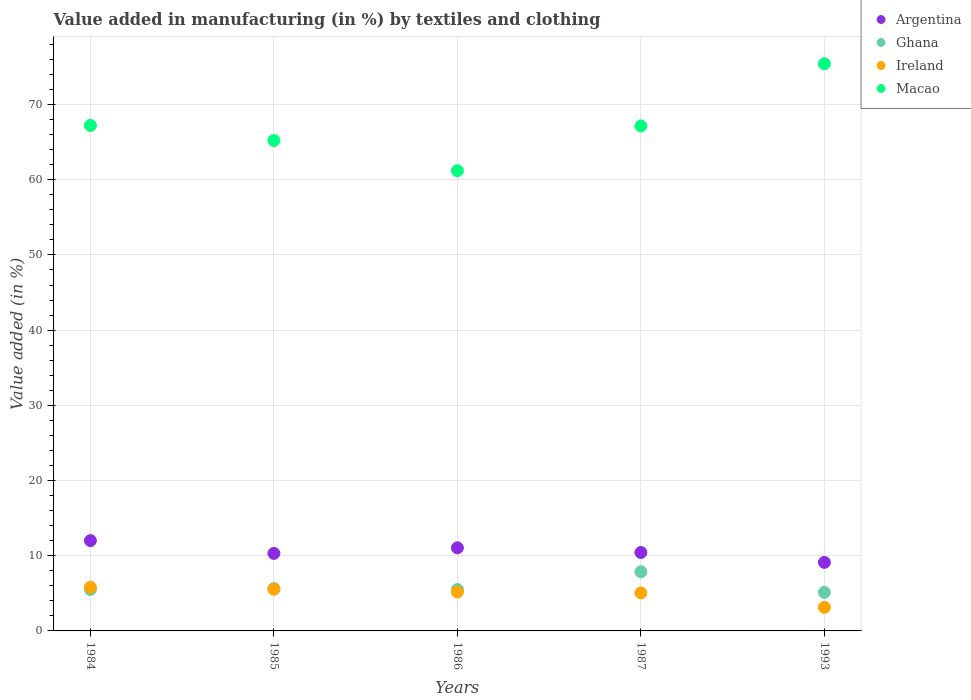What is the percentage of value added in manufacturing by textiles and clothing in Macao in 1987?
Provide a short and direct response. 67.15. Across all years, what is the maximum percentage of value added in manufacturing by textiles and clothing in Argentina?
Offer a terse response. 12.01. Across all years, what is the minimum percentage of value added in manufacturing by textiles and clothing in Macao?
Your answer should be compact. 61.21. In which year was the percentage of value added in manufacturing by textiles and clothing in Macao maximum?
Make the answer very short. 1993. In which year was the percentage of value added in manufacturing by textiles and clothing in Ireland minimum?
Offer a very short reply. 1993. What is the total percentage of value added in manufacturing by textiles and clothing in Ireland in the graph?
Ensure brevity in your answer.  24.72. What is the difference between the percentage of value added in manufacturing by textiles and clothing in Ireland in 1984 and that in 1986?
Your answer should be very brief. 0.62. What is the difference between the percentage of value added in manufacturing by textiles and clothing in Ireland in 1984 and the percentage of value added in manufacturing by textiles and clothing in Macao in 1987?
Offer a very short reply. -61.35. What is the average percentage of value added in manufacturing by textiles and clothing in Ghana per year?
Provide a succinct answer. 5.93. In the year 1986, what is the difference between the percentage of value added in manufacturing by textiles and clothing in Ireland and percentage of value added in manufacturing by textiles and clothing in Ghana?
Provide a short and direct response. -0.32. In how many years, is the percentage of value added in manufacturing by textiles and clothing in Argentina greater than 66 %?
Offer a terse response. 0. What is the ratio of the percentage of value added in manufacturing by textiles and clothing in Ghana in 1984 to that in 1987?
Ensure brevity in your answer.  0.7. Is the percentage of value added in manufacturing by textiles and clothing in Ghana in 1985 less than that in 1986?
Make the answer very short. No. Is the difference between the percentage of value added in manufacturing by textiles and clothing in Ireland in 1984 and 1987 greater than the difference between the percentage of value added in manufacturing by textiles and clothing in Ghana in 1984 and 1987?
Your answer should be very brief. Yes. What is the difference between the highest and the second highest percentage of value added in manufacturing by textiles and clothing in Macao?
Offer a terse response. 8.2. What is the difference between the highest and the lowest percentage of value added in manufacturing by textiles and clothing in Macao?
Ensure brevity in your answer.  14.22. Is it the case that in every year, the sum of the percentage of value added in manufacturing by textiles and clothing in Ghana and percentage of value added in manufacturing by textiles and clothing in Macao  is greater than the sum of percentage of value added in manufacturing by textiles and clothing in Ireland and percentage of value added in manufacturing by textiles and clothing in Argentina?
Offer a very short reply. Yes. Is the percentage of value added in manufacturing by textiles and clothing in Argentina strictly greater than the percentage of value added in manufacturing by textiles and clothing in Ireland over the years?
Provide a succinct answer. Yes. Is the percentage of value added in manufacturing by textiles and clothing in Ghana strictly less than the percentage of value added in manufacturing by textiles and clothing in Macao over the years?
Offer a terse response. Yes. How many dotlines are there?
Your answer should be compact. 4. What is the difference between two consecutive major ticks on the Y-axis?
Your answer should be very brief. 10. Are the values on the major ticks of Y-axis written in scientific E-notation?
Provide a succinct answer. No. Does the graph contain any zero values?
Your answer should be very brief. No. Does the graph contain grids?
Ensure brevity in your answer.  Yes. What is the title of the graph?
Offer a very short reply. Value added in manufacturing (in %) by textiles and clothing. Does "Slovenia" appear as one of the legend labels in the graph?
Ensure brevity in your answer.  No. What is the label or title of the X-axis?
Your response must be concise. Years. What is the label or title of the Y-axis?
Your answer should be very brief. Value added (in %). What is the Value added (in %) of Argentina in 1984?
Give a very brief answer. 12.01. What is the Value added (in %) of Ghana in 1984?
Keep it short and to the point. 5.51. What is the Value added (in %) in Ireland in 1984?
Offer a terse response. 5.81. What is the Value added (in %) of Macao in 1984?
Keep it short and to the point. 67.23. What is the Value added (in %) in Argentina in 1985?
Ensure brevity in your answer.  10.31. What is the Value added (in %) of Ghana in 1985?
Give a very brief answer. 5.64. What is the Value added (in %) of Ireland in 1985?
Provide a short and direct response. 5.54. What is the Value added (in %) of Macao in 1985?
Keep it short and to the point. 65.22. What is the Value added (in %) of Argentina in 1986?
Your response must be concise. 11.05. What is the Value added (in %) of Ghana in 1986?
Offer a terse response. 5.51. What is the Value added (in %) of Ireland in 1986?
Make the answer very short. 5.18. What is the Value added (in %) of Macao in 1986?
Provide a short and direct response. 61.21. What is the Value added (in %) of Argentina in 1987?
Make the answer very short. 10.43. What is the Value added (in %) of Ghana in 1987?
Keep it short and to the point. 7.87. What is the Value added (in %) in Ireland in 1987?
Give a very brief answer. 5.06. What is the Value added (in %) of Macao in 1987?
Your answer should be very brief. 67.15. What is the Value added (in %) of Argentina in 1993?
Give a very brief answer. 9.12. What is the Value added (in %) in Ghana in 1993?
Provide a succinct answer. 5.13. What is the Value added (in %) in Ireland in 1993?
Your response must be concise. 3.13. What is the Value added (in %) of Macao in 1993?
Make the answer very short. 75.43. Across all years, what is the maximum Value added (in %) in Argentina?
Provide a succinct answer. 12.01. Across all years, what is the maximum Value added (in %) in Ghana?
Your answer should be very brief. 7.87. Across all years, what is the maximum Value added (in %) in Ireland?
Keep it short and to the point. 5.81. Across all years, what is the maximum Value added (in %) of Macao?
Provide a succinct answer. 75.43. Across all years, what is the minimum Value added (in %) in Argentina?
Make the answer very short. 9.12. Across all years, what is the minimum Value added (in %) of Ghana?
Offer a terse response. 5.13. Across all years, what is the minimum Value added (in %) in Ireland?
Keep it short and to the point. 3.13. Across all years, what is the minimum Value added (in %) of Macao?
Provide a short and direct response. 61.21. What is the total Value added (in %) of Argentina in the graph?
Keep it short and to the point. 52.91. What is the total Value added (in %) of Ghana in the graph?
Your response must be concise. 29.66. What is the total Value added (in %) of Ireland in the graph?
Make the answer very short. 24.72. What is the total Value added (in %) in Macao in the graph?
Your answer should be very brief. 336.24. What is the difference between the Value added (in %) in Argentina in 1984 and that in 1985?
Give a very brief answer. 1.7. What is the difference between the Value added (in %) of Ghana in 1984 and that in 1985?
Your answer should be compact. -0.13. What is the difference between the Value added (in %) of Ireland in 1984 and that in 1985?
Keep it short and to the point. 0.27. What is the difference between the Value added (in %) of Macao in 1984 and that in 1985?
Offer a very short reply. 2. What is the difference between the Value added (in %) in Ghana in 1984 and that in 1986?
Your response must be concise. 0. What is the difference between the Value added (in %) in Ireland in 1984 and that in 1986?
Ensure brevity in your answer.  0.62. What is the difference between the Value added (in %) in Macao in 1984 and that in 1986?
Give a very brief answer. 6.02. What is the difference between the Value added (in %) of Argentina in 1984 and that in 1987?
Your response must be concise. 1.58. What is the difference between the Value added (in %) of Ghana in 1984 and that in 1987?
Provide a short and direct response. -2.36. What is the difference between the Value added (in %) of Ireland in 1984 and that in 1987?
Keep it short and to the point. 0.75. What is the difference between the Value added (in %) in Macao in 1984 and that in 1987?
Your answer should be compact. 0.08. What is the difference between the Value added (in %) of Argentina in 1984 and that in 1993?
Your response must be concise. 2.89. What is the difference between the Value added (in %) of Ghana in 1984 and that in 1993?
Your answer should be compact. 0.38. What is the difference between the Value added (in %) in Ireland in 1984 and that in 1993?
Give a very brief answer. 2.67. What is the difference between the Value added (in %) of Macao in 1984 and that in 1993?
Make the answer very short. -8.2. What is the difference between the Value added (in %) of Argentina in 1985 and that in 1986?
Ensure brevity in your answer.  -0.74. What is the difference between the Value added (in %) in Ghana in 1985 and that in 1986?
Your response must be concise. 0.14. What is the difference between the Value added (in %) of Ireland in 1985 and that in 1986?
Your answer should be very brief. 0.35. What is the difference between the Value added (in %) of Macao in 1985 and that in 1986?
Provide a succinct answer. 4.02. What is the difference between the Value added (in %) in Argentina in 1985 and that in 1987?
Your answer should be compact. -0.12. What is the difference between the Value added (in %) of Ghana in 1985 and that in 1987?
Your response must be concise. -2.23. What is the difference between the Value added (in %) in Ireland in 1985 and that in 1987?
Offer a very short reply. 0.48. What is the difference between the Value added (in %) in Macao in 1985 and that in 1987?
Ensure brevity in your answer.  -1.93. What is the difference between the Value added (in %) in Argentina in 1985 and that in 1993?
Keep it short and to the point. 1.19. What is the difference between the Value added (in %) in Ghana in 1985 and that in 1993?
Keep it short and to the point. 0.51. What is the difference between the Value added (in %) in Ireland in 1985 and that in 1993?
Your answer should be very brief. 2.41. What is the difference between the Value added (in %) of Macao in 1985 and that in 1993?
Your response must be concise. -10.21. What is the difference between the Value added (in %) in Argentina in 1986 and that in 1987?
Offer a very short reply. 0.62. What is the difference between the Value added (in %) of Ghana in 1986 and that in 1987?
Offer a terse response. -2.36. What is the difference between the Value added (in %) in Ireland in 1986 and that in 1987?
Keep it short and to the point. 0.13. What is the difference between the Value added (in %) of Macao in 1986 and that in 1987?
Keep it short and to the point. -5.94. What is the difference between the Value added (in %) in Argentina in 1986 and that in 1993?
Give a very brief answer. 1.93. What is the difference between the Value added (in %) of Ghana in 1986 and that in 1993?
Give a very brief answer. 0.38. What is the difference between the Value added (in %) in Ireland in 1986 and that in 1993?
Make the answer very short. 2.05. What is the difference between the Value added (in %) in Macao in 1986 and that in 1993?
Offer a terse response. -14.22. What is the difference between the Value added (in %) in Argentina in 1987 and that in 1993?
Make the answer very short. 1.31. What is the difference between the Value added (in %) in Ghana in 1987 and that in 1993?
Make the answer very short. 2.74. What is the difference between the Value added (in %) in Ireland in 1987 and that in 1993?
Your answer should be very brief. 1.93. What is the difference between the Value added (in %) in Macao in 1987 and that in 1993?
Offer a terse response. -8.28. What is the difference between the Value added (in %) of Argentina in 1984 and the Value added (in %) of Ghana in 1985?
Keep it short and to the point. 6.36. What is the difference between the Value added (in %) in Argentina in 1984 and the Value added (in %) in Ireland in 1985?
Your answer should be very brief. 6.47. What is the difference between the Value added (in %) of Argentina in 1984 and the Value added (in %) of Macao in 1985?
Make the answer very short. -53.22. What is the difference between the Value added (in %) in Ghana in 1984 and the Value added (in %) in Ireland in 1985?
Your response must be concise. -0.03. What is the difference between the Value added (in %) of Ghana in 1984 and the Value added (in %) of Macao in 1985?
Offer a very short reply. -59.71. What is the difference between the Value added (in %) of Ireland in 1984 and the Value added (in %) of Macao in 1985?
Provide a short and direct response. -59.42. What is the difference between the Value added (in %) of Argentina in 1984 and the Value added (in %) of Ghana in 1986?
Provide a short and direct response. 6.5. What is the difference between the Value added (in %) of Argentina in 1984 and the Value added (in %) of Ireland in 1986?
Keep it short and to the point. 6.82. What is the difference between the Value added (in %) in Argentina in 1984 and the Value added (in %) in Macao in 1986?
Ensure brevity in your answer.  -49.2. What is the difference between the Value added (in %) in Ghana in 1984 and the Value added (in %) in Ireland in 1986?
Offer a terse response. 0.33. What is the difference between the Value added (in %) in Ghana in 1984 and the Value added (in %) in Macao in 1986?
Make the answer very short. -55.7. What is the difference between the Value added (in %) of Ireland in 1984 and the Value added (in %) of Macao in 1986?
Offer a very short reply. -55.4. What is the difference between the Value added (in %) in Argentina in 1984 and the Value added (in %) in Ghana in 1987?
Provide a succinct answer. 4.14. What is the difference between the Value added (in %) in Argentina in 1984 and the Value added (in %) in Ireland in 1987?
Provide a succinct answer. 6.95. What is the difference between the Value added (in %) of Argentina in 1984 and the Value added (in %) of Macao in 1987?
Keep it short and to the point. -55.14. What is the difference between the Value added (in %) in Ghana in 1984 and the Value added (in %) in Ireland in 1987?
Ensure brevity in your answer.  0.45. What is the difference between the Value added (in %) in Ghana in 1984 and the Value added (in %) in Macao in 1987?
Provide a succinct answer. -61.64. What is the difference between the Value added (in %) in Ireland in 1984 and the Value added (in %) in Macao in 1987?
Keep it short and to the point. -61.35. What is the difference between the Value added (in %) in Argentina in 1984 and the Value added (in %) in Ghana in 1993?
Your answer should be very brief. 6.88. What is the difference between the Value added (in %) of Argentina in 1984 and the Value added (in %) of Ireland in 1993?
Give a very brief answer. 8.88. What is the difference between the Value added (in %) of Argentina in 1984 and the Value added (in %) of Macao in 1993?
Offer a terse response. -63.42. What is the difference between the Value added (in %) of Ghana in 1984 and the Value added (in %) of Ireland in 1993?
Your answer should be compact. 2.38. What is the difference between the Value added (in %) in Ghana in 1984 and the Value added (in %) in Macao in 1993?
Keep it short and to the point. -69.92. What is the difference between the Value added (in %) of Ireland in 1984 and the Value added (in %) of Macao in 1993?
Your response must be concise. -69.62. What is the difference between the Value added (in %) in Argentina in 1985 and the Value added (in %) in Ghana in 1986?
Keep it short and to the point. 4.8. What is the difference between the Value added (in %) of Argentina in 1985 and the Value added (in %) of Ireland in 1986?
Your response must be concise. 5.13. What is the difference between the Value added (in %) in Argentina in 1985 and the Value added (in %) in Macao in 1986?
Give a very brief answer. -50.9. What is the difference between the Value added (in %) of Ghana in 1985 and the Value added (in %) of Ireland in 1986?
Offer a very short reply. 0.46. What is the difference between the Value added (in %) of Ghana in 1985 and the Value added (in %) of Macao in 1986?
Make the answer very short. -55.56. What is the difference between the Value added (in %) of Ireland in 1985 and the Value added (in %) of Macao in 1986?
Keep it short and to the point. -55.67. What is the difference between the Value added (in %) in Argentina in 1985 and the Value added (in %) in Ghana in 1987?
Your answer should be compact. 2.44. What is the difference between the Value added (in %) of Argentina in 1985 and the Value added (in %) of Ireland in 1987?
Your response must be concise. 5.25. What is the difference between the Value added (in %) in Argentina in 1985 and the Value added (in %) in Macao in 1987?
Your response must be concise. -56.84. What is the difference between the Value added (in %) in Ghana in 1985 and the Value added (in %) in Ireland in 1987?
Make the answer very short. 0.59. What is the difference between the Value added (in %) of Ghana in 1985 and the Value added (in %) of Macao in 1987?
Keep it short and to the point. -61.51. What is the difference between the Value added (in %) in Ireland in 1985 and the Value added (in %) in Macao in 1987?
Your response must be concise. -61.61. What is the difference between the Value added (in %) in Argentina in 1985 and the Value added (in %) in Ghana in 1993?
Your response must be concise. 5.18. What is the difference between the Value added (in %) of Argentina in 1985 and the Value added (in %) of Ireland in 1993?
Your answer should be compact. 7.18. What is the difference between the Value added (in %) of Argentina in 1985 and the Value added (in %) of Macao in 1993?
Provide a short and direct response. -65.12. What is the difference between the Value added (in %) of Ghana in 1985 and the Value added (in %) of Ireland in 1993?
Your answer should be compact. 2.51. What is the difference between the Value added (in %) of Ghana in 1985 and the Value added (in %) of Macao in 1993?
Ensure brevity in your answer.  -69.79. What is the difference between the Value added (in %) in Ireland in 1985 and the Value added (in %) in Macao in 1993?
Offer a very short reply. -69.89. What is the difference between the Value added (in %) in Argentina in 1986 and the Value added (in %) in Ghana in 1987?
Your response must be concise. 3.18. What is the difference between the Value added (in %) in Argentina in 1986 and the Value added (in %) in Ireland in 1987?
Make the answer very short. 5.99. What is the difference between the Value added (in %) of Argentina in 1986 and the Value added (in %) of Macao in 1987?
Ensure brevity in your answer.  -56.1. What is the difference between the Value added (in %) in Ghana in 1986 and the Value added (in %) in Ireland in 1987?
Offer a very short reply. 0.45. What is the difference between the Value added (in %) of Ghana in 1986 and the Value added (in %) of Macao in 1987?
Make the answer very short. -61.64. What is the difference between the Value added (in %) of Ireland in 1986 and the Value added (in %) of Macao in 1987?
Your answer should be very brief. -61.97. What is the difference between the Value added (in %) of Argentina in 1986 and the Value added (in %) of Ghana in 1993?
Ensure brevity in your answer.  5.92. What is the difference between the Value added (in %) of Argentina in 1986 and the Value added (in %) of Ireland in 1993?
Offer a terse response. 7.92. What is the difference between the Value added (in %) of Argentina in 1986 and the Value added (in %) of Macao in 1993?
Provide a short and direct response. -64.38. What is the difference between the Value added (in %) in Ghana in 1986 and the Value added (in %) in Ireland in 1993?
Your response must be concise. 2.38. What is the difference between the Value added (in %) in Ghana in 1986 and the Value added (in %) in Macao in 1993?
Offer a very short reply. -69.92. What is the difference between the Value added (in %) of Ireland in 1986 and the Value added (in %) of Macao in 1993?
Provide a succinct answer. -70.24. What is the difference between the Value added (in %) of Argentina in 1987 and the Value added (in %) of Ghana in 1993?
Provide a short and direct response. 5.3. What is the difference between the Value added (in %) in Argentina in 1987 and the Value added (in %) in Ireland in 1993?
Give a very brief answer. 7.3. What is the difference between the Value added (in %) in Argentina in 1987 and the Value added (in %) in Macao in 1993?
Give a very brief answer. -65. What is the difference between the Value added (in %) of Ghana in 1987 and the Value added (in %) of Ireland in 1993?
Provide a succinct answer. 4.74. What is the difference between the Value added (in %) of Ghana in 1987 and the Value added (in %) of Macao in 1993?
Keep it short and to the point. -67.56. What is the difference between the Value added (in %) in Ireland in 1987 and the Value added (in %) in Macao in 1993?
Keep it short and to the point. -70.37. What is the average Value added (in %) in Argentina per year?
Give a very brief answer. 10.58. What is the average Value added (in %) in Ghana per year?
Your answer should be compact. 5.93. What is the average Value added (in %) in Ireland per year?
Make the answer very short. 4.94. What is the average Value added (in %) of Macao per year?
Offer a very short reply. 67.25. In the year 1984, what is the difference between the Value added (in %) of Argentina and Value added (in %) of Ghana?
Ensure brevity in your answer.  6.5. In the year 1984, what is the difference between the Value added (in %) of Argentina and Value added (in %) of Ireland?
Give a very brief answer. 6.2. In the year 1984, what is the difference between the Value added (in %) of Argentina and Value added (in %) of Macao?
Your answer should be compact. -55.22. In the year 1984, what is the difference between the Value added (in %) of Ghana and Value added (in %) of Ireland?
Provide a short and direct response. -0.29. In the year 1984, what is the difference between the Value added (in %) of Ghana and Value added (in %) of Macao?
Keep it short and to the point. -61.72. In the year 1984, what is the difference between the Value added (in %) of Ireland and Value added (in %) of Macao?
Offer a very short reply. -61.42. In the year 1985, what is the difference between the Value added (in %) of Argentina and Value added (in %) of Ghana?
Your answer should be compact. 4.67. In the year 1985, what is the difference between the Value added (in %) of Argentina and Value added (in %) of Ireland?
Offer a very short reply. 4.77. In the year 1985, what is the difference between the Value added (in %) of Argentina and Value added (in %) of Macao?
Ensure brevity in your answer.  -54.91. In the year 1985, what is the difference between the Value added (in %) in Ghana and Value added (in %) in Ireland?
Provide a short and direct response. 0.1. In the year 1985, what is the difference between the Value added (in %) of Ghana and Value added (in %) of Macao?
Make the answer very short. -59.58. In the year 1985, what is the difference between the Value added (in %) in Ireland and Value added (in %) in Macao?
Keep it short and to the point. -59.68. In the year 1986, what is the difference between the Value added (in %) of Argentina and Value added (in %) of Ghana?
Provide a succinct answer. 5.54. In the year 1986, what is the difference between the Value added (in %) of Argentina and Value added (in %) of Ireland?
Provide a succinct answer. 5.87. In the year 1986, what is the difference between the Value added (in %) of Argentina and Value added (in %) of Macao?
Your answer should be very brief. -50.16. In the year 1986, what is the difference between the Value added (in %) of Ghana and Value added (in %) of Ireland?
Offer a very short reply. 0.32. In the year 1986, what is the difference between the Value added (in %) of Ghana and Value added (in %) of Macao?
Your answer should be compact. -55.7. In the year 1986, what is the difference between the Value added (in %) in Ireland and Value added (in %) in Macao?
Your answer should be compact. -56.02. In the year 1987, what is the difference between the Value added (in %) of Argentina and Value added (in %) of Ghana?
Offer a very short reply. 2.56. In the year 1987, what is the difference between the Value added (in %) of Argentina and Value added (in %) of Ireland?
Give a very brief answer. 5.37. In the year 1987, what is the difference between the Value added (in %) of Argentina and Value added (in %) of Macao?
Keep it short and to the point. -56.72. In the year 1987, what is the difference between the Value added (in %) of Ghana and Value added (in %) of Ireland?
Give a very brief answer. 2.81. In the year 1987, what is the difference between the Value added (in %) in Ghana and Value added (in %) in Macao?
Provide a succinct answer. -59.28. In the year 1987, what is the difference between the Value added (in %) of Ireland and Value added (in %) of Macao?
Your answer should be very brief. -62.09. In the year 1993, what is the difference between the Value added (in %) of Argentina and Value added (in %) of Ghana?
Give a very brief answer. 3.99. In the year 1993, what is the difference between the Value added (in %) in Argentina and Value added (in %) in Ireland?
Your answer should be compact. 5.99. In the year 1993, what is the difference between the Value added (in %) in Argentina and Value added (in %) in Macao?
Keep it short and to the point. -66.31. In the year 1993, what is the difference between the Value added (in %) of Ghana and Value added (in %) of Ireland?
Ensure brevity in your answer.  2. In the year 1993, what is the difference between the Value added (in %) in Ghana and Value added (in %) in Macao?
Offer a very short reply. -70.3. In the year 1993, what is the difference between the Value added (in %) of Ireland and Value added (in %) of Macao?
Offer a very short reply. -72.3. What is the ratio of the Value added (in %) of Argentina in 1984 to that in 1985?
Your response must be concise. 1.16. What is the ratio of the Value added (in %) of Ghana in 1984 to that in 1985?
Your response must be concise. 0.98. What is the ratio of the Value added (in %) in Ireland in 1984 to that in 1985?
Offer a very short reply. 1.05. What is the ratio of the Value added (in %) in Macao in 1984 to that in 1985?
Your answer should be compact. 1.03. What is the ratio of the Value added (in %) in Argentina in 1984 to that in 1986?
Your response must be concise. 1.09. What is the ratio of the Value added (in %) of Ireland in 1984 to that in 1986?
Provide a short and direct response. 1.12. What is the ratio of the Value added (in %) of Macao in 1984 to that in 1986?
Ensure brevity in your answer.  1.1. What is the ratio of the Value added (in %) in Argentina in 1984 to that in 1987?
Your answer should be very brief. 1.15. What is the ratio of the Value added (in %) of Ghana in 1984 to that in 1987?
Ensure brevity in your answer.  0.7. What is the ratio of the Value added (in %) of Ireland in 1984 to that in 1987?
Provide a short and direct response. 1.15. What is the ratio of the Value added (in %) of Macao in 1984 to that in 1987?
Provide a short and direct response. 1. What is the ratio of the Value added (in %) in Argentina in 1984 to that in 1993?
Your answer should be very brief. 1.32. What is the ratio of the Value added (in %) of Ghana in 1984 to that in 1993?
Your answer should be compact. 1.07. What is the ratio of the Value added (in %) in Ireland in 1984 to that in 1993?
Your answer should be very brief. 1.85. What is the ratio of the Value added (in %) in Macao in 1984 to that in 1993?
Provide a short and direct response. 0.89. What is the ratio of the Value added (in %) in Argentina in 1985 to that in 1986?
Your answer should be compact. 0.93. What is the ratio of the Value added (in %) of Ghana in 1985 to that in 1986?
Offer a terse response. 1.02. What is the ratio of the Value added (in %) of Ireland in 1985 to that in 1986?
Keep it short and to the point. 1.07. What is the ratio of the Value added (in %) of Macao in 1985 to that in 1986?
Your answer should be very brief. 1.07. What is the ratio of the Value added (in %) in Argentina in 1985 to that in 1987?
Offer a very short reply. 0.99. What is the ratio of the Value added (in %) of Ghana in 1985 to that in 1987?
Your answer should be compact. 0.72. What is the ratio of the Value added (in %) of Ireland in 1985 to that in 1987?
Provide a short and direct response. 1.1. What is the ratio of the Value added (in %) of Macao in 1985 to that in 1987?
Provide a short and direct response. 0.97. What is the ratio of the Value added (in %) of Argentina in 1985 to that in 1993?
Your answer should be compact. 1.13. What is the ratio of the Value added (in %) in Ghana in 1985 to that in 1993?
Your answer should be very brief. 1.1. What is the ratio of the Value added (in %) of Ireland in 1985 to that in 1993?
Your answer should be compact. 1.77. What is the ratio of the Value added (in %) of Macao in 1985 to that in 1993?
Give a very brief answer. 0.86. What is the ratio of the Value added (in %) of Argentina in 1986 to that in 1987?
Your answer should be very brief. 1.06. What is the ratio of the Value added (in %) of Ghana in 1986 to that in 1987?
Give a very brief answer. 0.7. What is the ratio of the Value added (in %) of Ireland in 1986 to that in 1987?
Offer a terse response. 1.03. What is the ratio of the Value added (in %) in Macao in 1986 to that in 1987?
Your response must be concise. 0.91. What is the ratio of the Value added (in %) in Argentina in 1986 to that in 1993?
Ensure brevity in your answer.  1.21. What is the ratio of the Value added (in %) of Ghana in 1986 to that in 1993?
Your answer should be compact. 1.07. What is the ratio of the Value added (in %) in Ireland in 1986 to that in 1993?
Your answer should be compact. 1.66. What is the ratio of the Value added (in %) of Macao in 1986 to that in 1993?
Give a very brief answer. 0.81. What is the ratio of the Value added (in %) of Argentina in 1987 to that in 1993?
Your answer should be compact. 1.14. What is the ratio of the Value added (in %) of Ghana in 1987 to that in 1993?
Offer a very short reply. 1.53. What is the ratio of the Value added (in %) in Ireland in 1987 to that in 1993?
Give a very brief answer. 1.61. What is the ratio of the Value added (in %) in Macao in 1987 to that in 1993?
Your response must be concise. 0.89. What is the difference between the highest and the second highest Value added (in %) in Argentina?
Give a very brief answer. 0.96. What is the difference between the highest and the second highest Value added (in %) in Ghana?
Provide a succinct answer. 2.23. What is the difference between the highest and the second highest Value added (in %) of Ireland?
Keep it short and to the point. 0.27. What is the difference between the highest and the second highest Value added (in %) in Macao?
Offer a very short reply. 8.2. What is the difference between the highest and the lowest Value added (in %) in Argentina?
Provide a short and direct response. 2.89. What is the difference between the highest and the lowest Value added (in %) of Ghana?
Offer a very short reply. 2.74. What is the difference between the highest and the lowest Value added (in %) of Ireland?
Your answer should be compact. 2.67. What is the difference between the highest and the lowest Value added (in %) of Macao?
Provide a short and direct response. 14.22. 